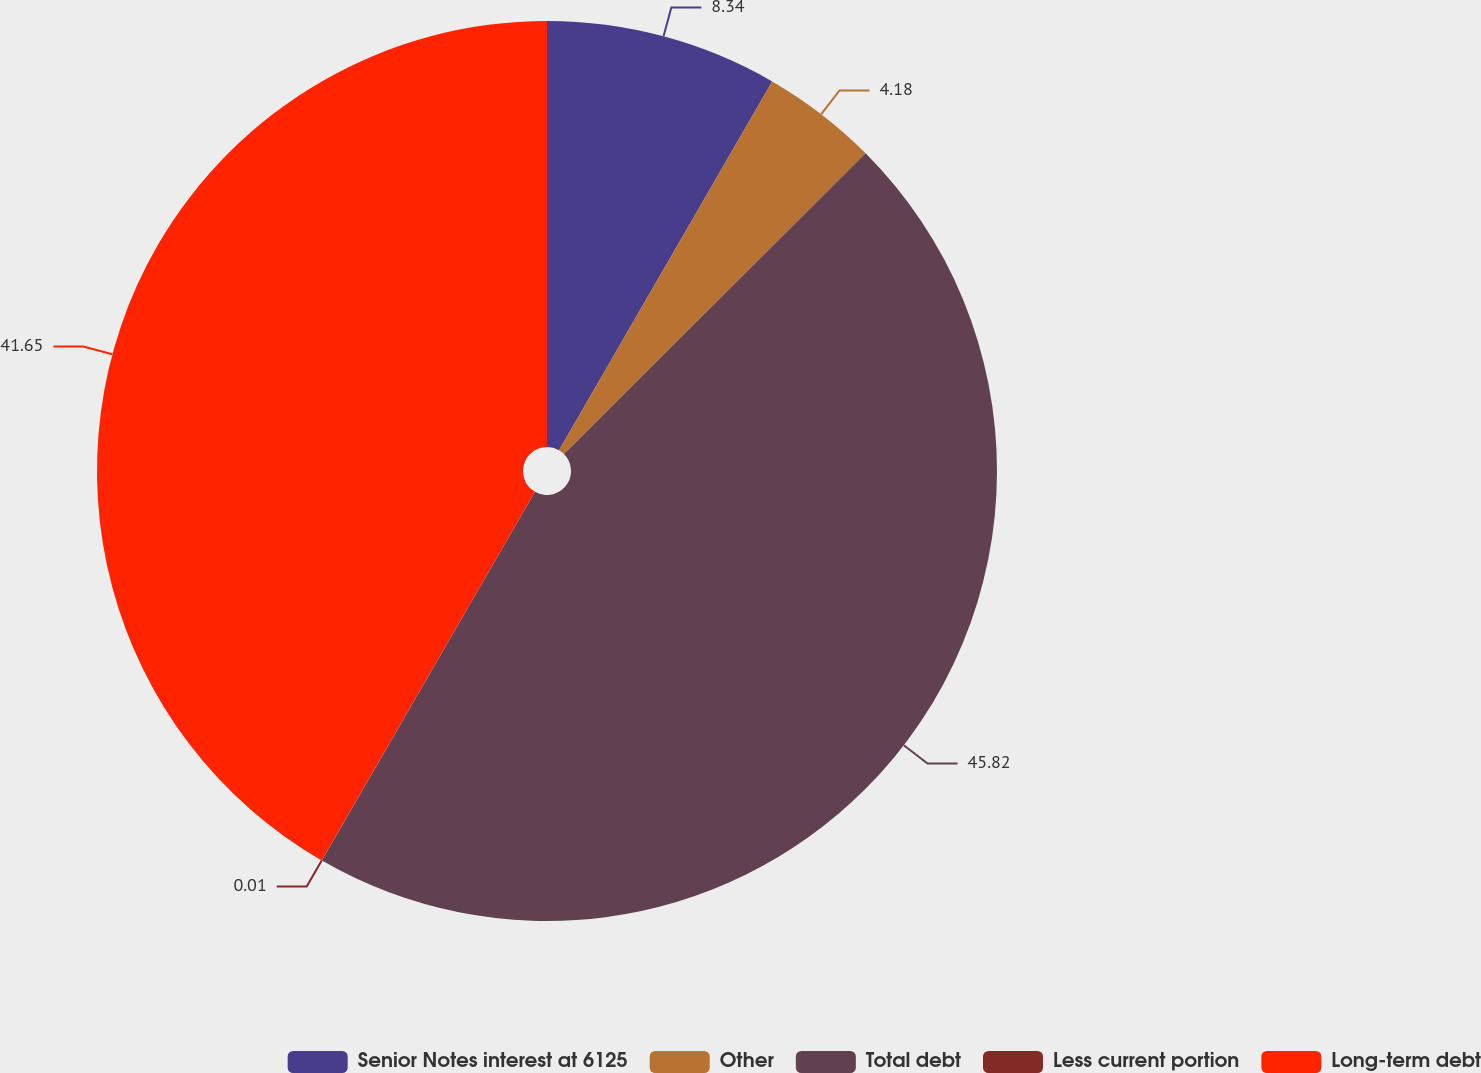Convert chart to OTSL. <chart><loc_0><loc_0><loc_500><loc_500><pie_chart><fcel>Senior Notes interest at 6125<fcel>Other<fcel>Total debt<fcel>Less current portion<fcel>Long-term debt<nl><fcel>8.34%<fcel>4.18%<fcel>45.82%<fcel>0.01%<fcel>41.65%<nl></chart> 